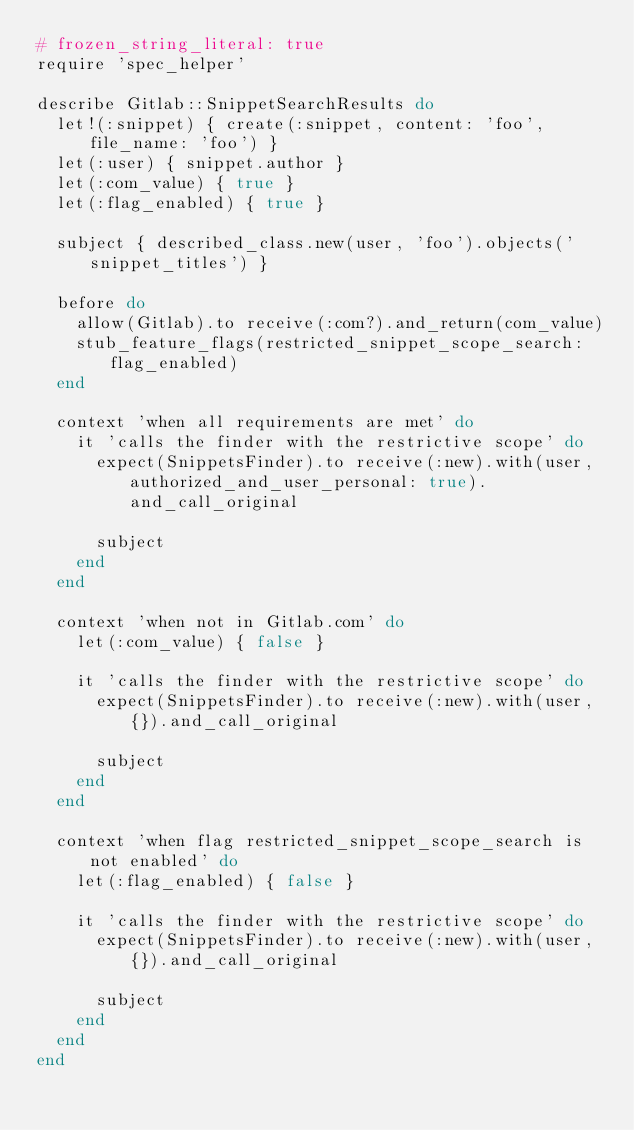Convert code to text. <code><loc_0><loc_0><loc_500><loc_500><_Ruby_># frozen_string_literal: true
require 'spec_helper'

describe Gitlab::SnippetSearchResults do
  let!(:snippet) { create(:snippet, content: 'foo', file_name: 'foo') }
  let(:user) { snippet.author }
  let(:com_value) { true }
  let(:flag_enabled) { true }

  subject { described_class.new(user, 'foo').objects('snippet_titles') }

  before do
    allow(Gitlab).to receive(:com?).and_return(com_value)
    stub_feature_flags(restricted_snippet_scope_search: flag_enabled)
  end

  context 'when all requirements are met' do
    it 'calls the finder with the restrictive scope' do
      expect(SnippetsFinder).to receive(:new).with(user, authorized_and_user_personal: true).and_call_original

      subject
    end
  end

  context 'when not in Gitlab.com' do
    let(:com_value) { false }

    it 'calls the finder with the restrictive scope' do
      expect(SnippetsFinder).to receive(:new).with(user, {}).and_call_original

      subject
    end
  end

  context 'when flag restricted_snippet_scope_search is not enabled' do
    let(:flag_enabled) { false }

    it 'calls the finder with the restrictive scope' do
      expect(SnippetsFinder).to receive(:new).with(user, {}).and_call_original

      subject
    end
  end
end
</code> 